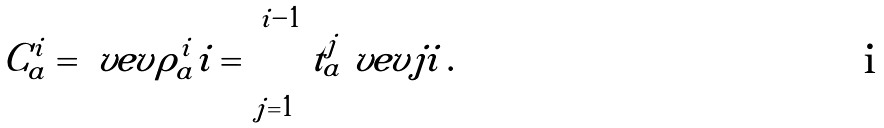<formula> <loc_0><loc_0><loc_500><loc_500>C _ { a } ^ { i } = \ v e v { \rho _ { a } ^ { i } i } = \sum _ { j = 1 } ^ { i - 1 } t _ { a } ^ { j } \ v e v { j i } \, .</formula> 